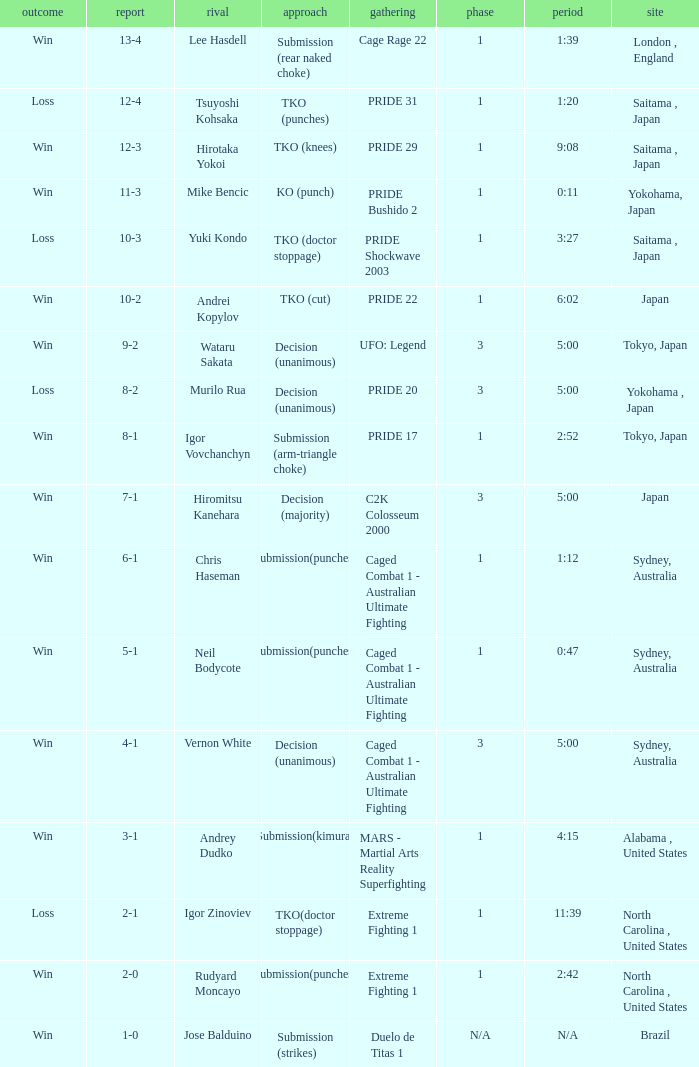Which Res has a Method of decision (unanimous) and an Opponent of Wataru Sakata? Win. 